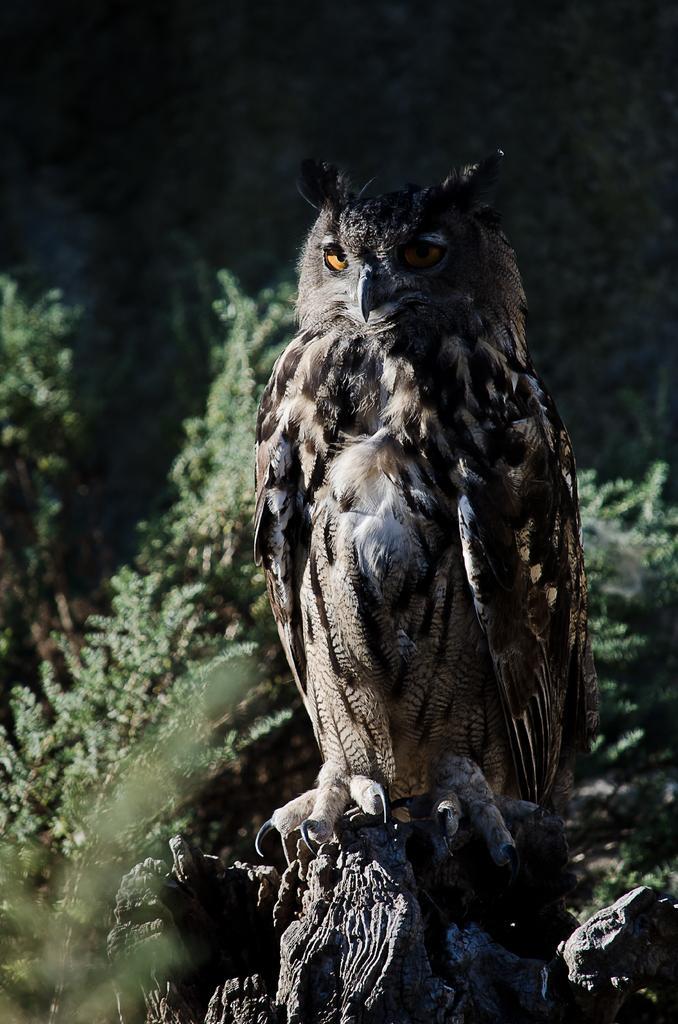Describe this image in one or two sentences. In this image there is an owl in the middle. In the background there are so many plants. 